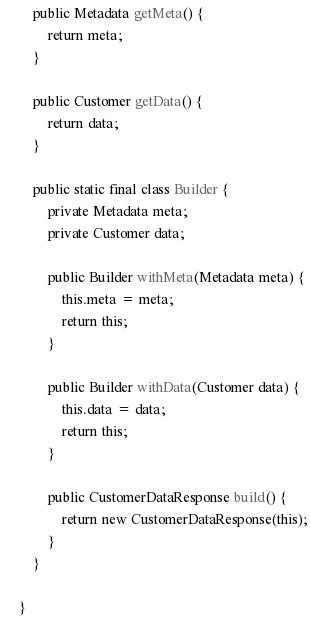<code> <loc_0><loc_0><loc_500><loc_500><_Java_>
    public Metadata getMeta() {
        return meta;
    }

    public Customer getData() {
        return data;
    }

    public static final class Builder {
        private Metadata meta;
        private Customer data;

        public Builder withMeta(Metadata meta) {
            this.meta = meta;
            return this;
        }

        public Builder withData(Customer data) {
            this.data = data;
            return this;
        }

        public CustomerDataResponse build() {
            return new CustomerDataResponse(this);
        }
    }

}
</code> 